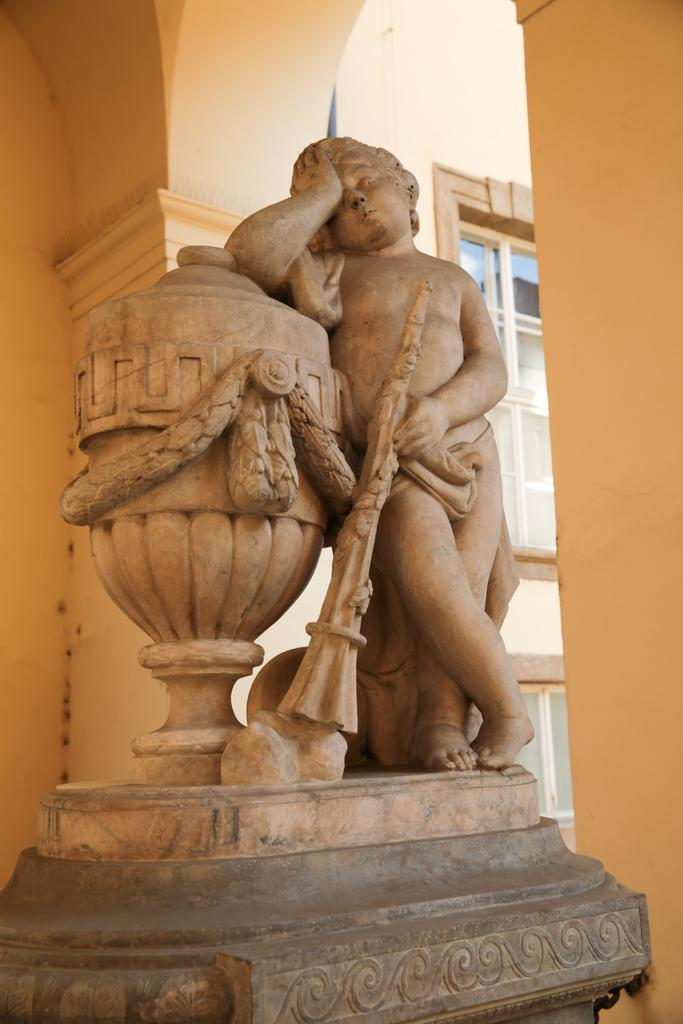What is the main subject of the image? There is a statue of a human in the image. How is the statue positioned in the image? The statue is standing. What can be seen in the background of the image? There are pillars and glass windows in the background of the image. What year is the statue's partner from in the image? There is no partner mentioned or visible in the image, and therefore no such information can be provided. 